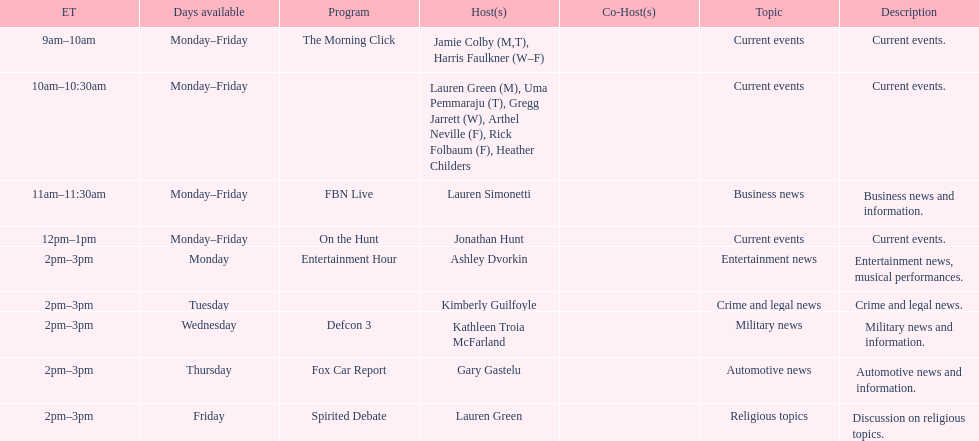How long does on the hunt run? 1 hour. 